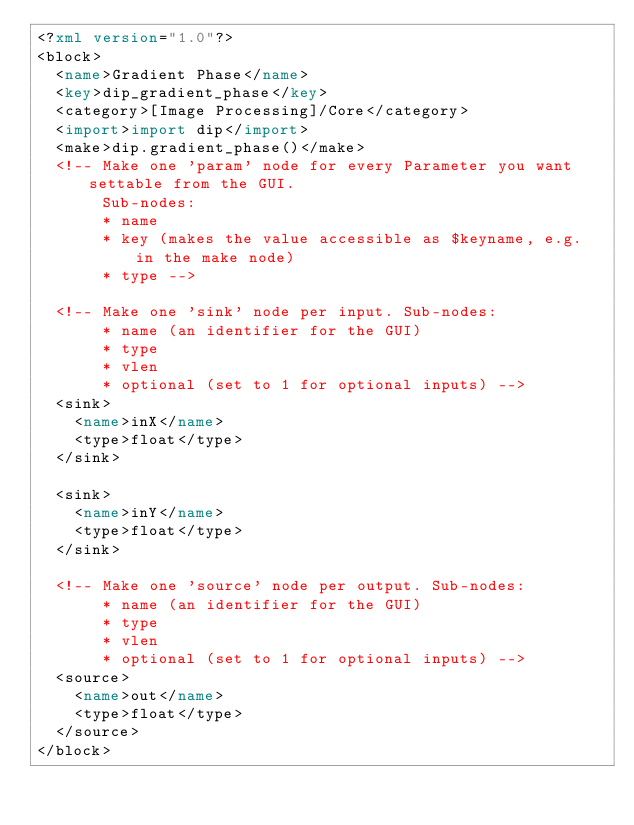Convert code to text. <code><loc_0><loc_0><loc_500><loc_500><_XML_><?xml version="1.0"?>
<block>
  <name>Gradient Phase</name>
  <key>dip_gradient_phase</key>
  <category>[Image Processing]/Core</category>
  <import>import dip</import>
  <make>dip.gradient_phase()</make>
  <!-- Make one 'param' node for every Parameter you want settable from the GUI.
       Sub-nodes:
       * name
       * key (makes the value accessible as $keyname, e.g. in the make node)
       * type -->

  <!-- Make one 'sink' node per input. Sub-nodes:
       * name (an identifier for the GUI)
       * type
       * vlen
       * optional (set to 1 for optional inputs) -->
  <sink>
    <name>inX</name>
    <type>float</type>
  </sink>

  <sink>
    <name>inY</name>
    <type>float</type>
  </sink>

  <!-- Make one 'source' node per output. Sub-nodes:
       * name (an identifier for the GUI)
       * type
       * vlen
       * optional (set to 1 for optional inputs) -->
  <source>
    <name>out</name>
    <type>float</type>
  </source>
</block>
</code> 